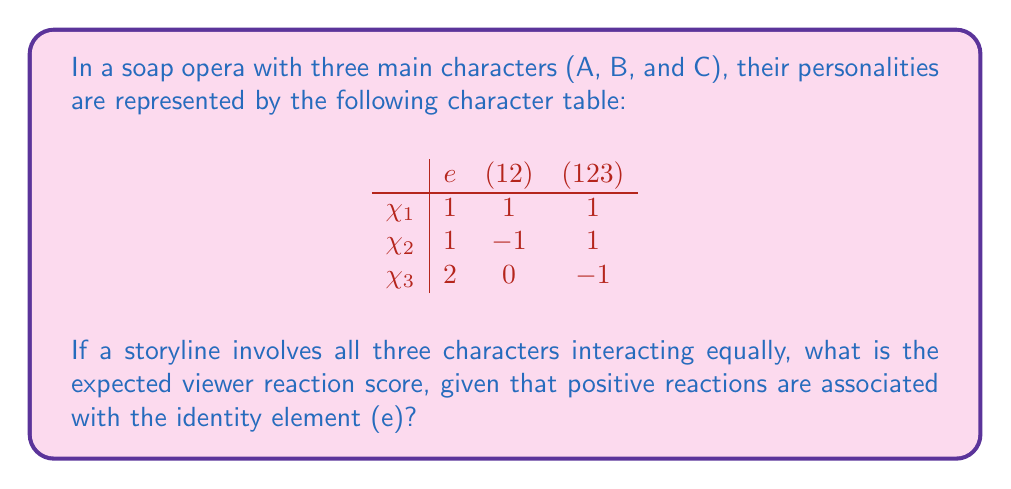Could you help me with this problem? Let's break this down step-by-step:

1) In character theory, the identity element (e) represents the most positive reaction. We need to focus on this column.

2) The sum of the squares of the entries in the first column (e) gives us the order of the group:
   $1^2 + 1^2 + 2^2 = 6$

3) To find the expected viewer reaction score, we need to calculate the average value in the e column:
   $\frac{1 + 1 + 2}{3} = \frac{4}{3}$

4) However, we need to normalize this by dividing by the order of the group:
   $\frac{4/3}{6} = \frac{2}{9}$

5) This fraction represents the expected positive reaction score for a storyline involving all characters equally.

6) To make it more relatable to our soap opera-obsessed teenager, we can express this as a percentage:
   $\frac{2}{9} \approx 0.2222 \approx 22.22\%$

So, the expected positive viewer reaction score is about 22.22%.
Answer: $\frac{2}{9}$ or $22.22\%$ 